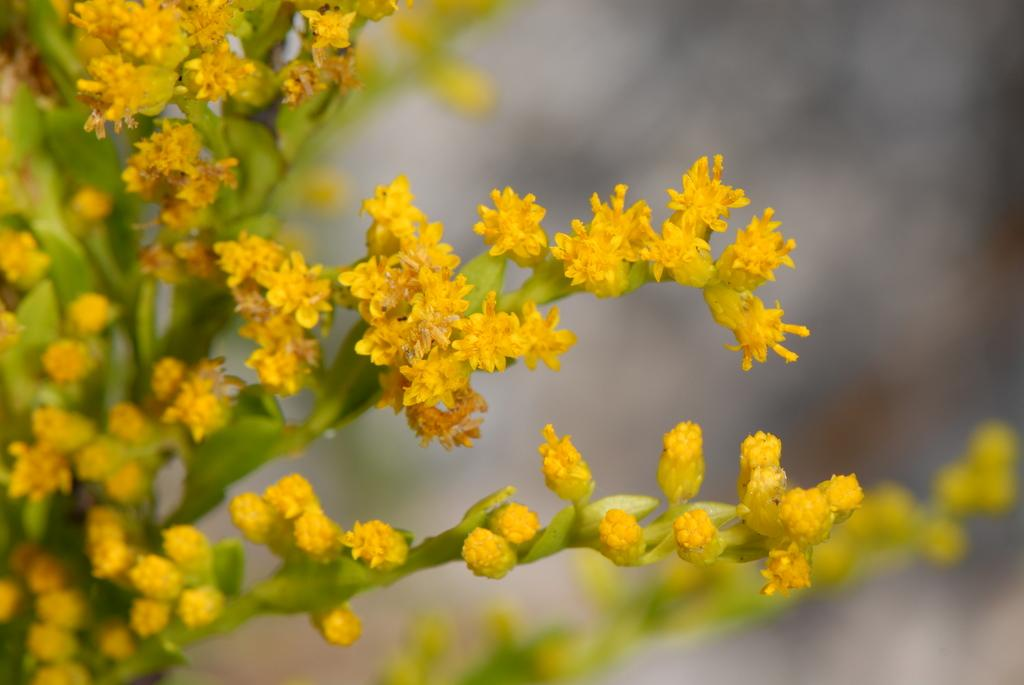What is located on the left side of the image? There is a plant on the left side of the image. What color are the flowers on the plant? The flowers on the plant are yellow. What color are the stems of the plant? The stems of the plant are green. How would you describe the background of the image? The background of the image is blurred. Who is the owner of the clam in the image? There is no clam present in the image, so it is not possible to determine the owner. 